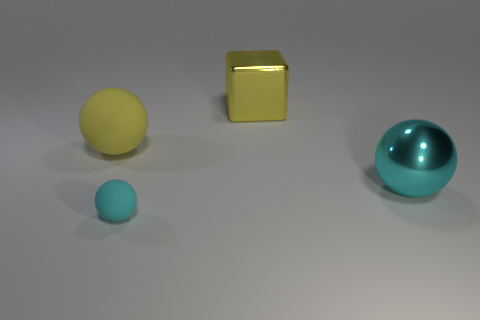Add 1 large matte spheres. How many objects exist? 5 Subtract all balls. How many objects are left? 1 Subtract all big cyan metallic balls. Subtract all large yellow rubber objects. How many objects are left? 2 Add 4 yellow blocks. How many yellow blocks are left? 5 Add 3 brown balls. How many brown balls exist? 3 Subtract 0 gray cylinders. How many objects are left? 4 